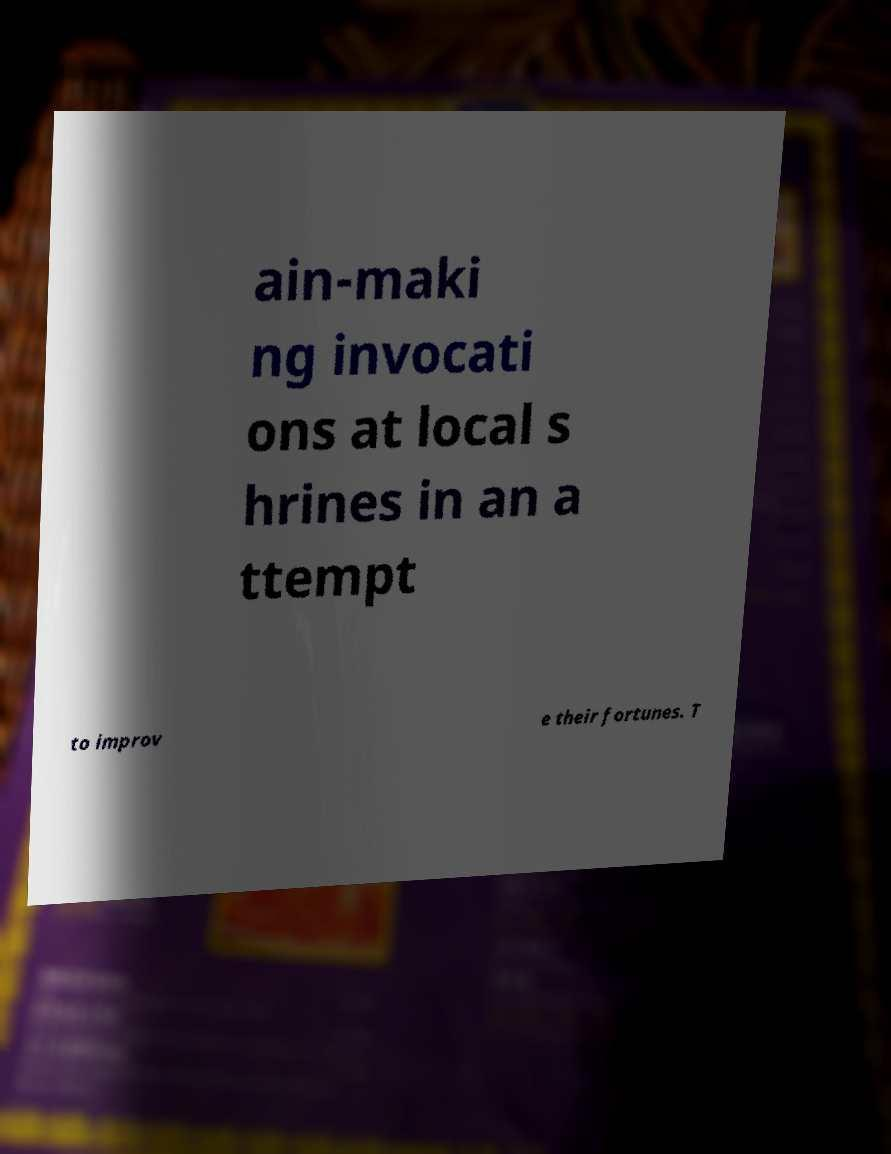Please identify and transcribe the text found in this image. ain-maki ng invocati ons at local s hrines in an a ttempt to improv e their fortunes. T 